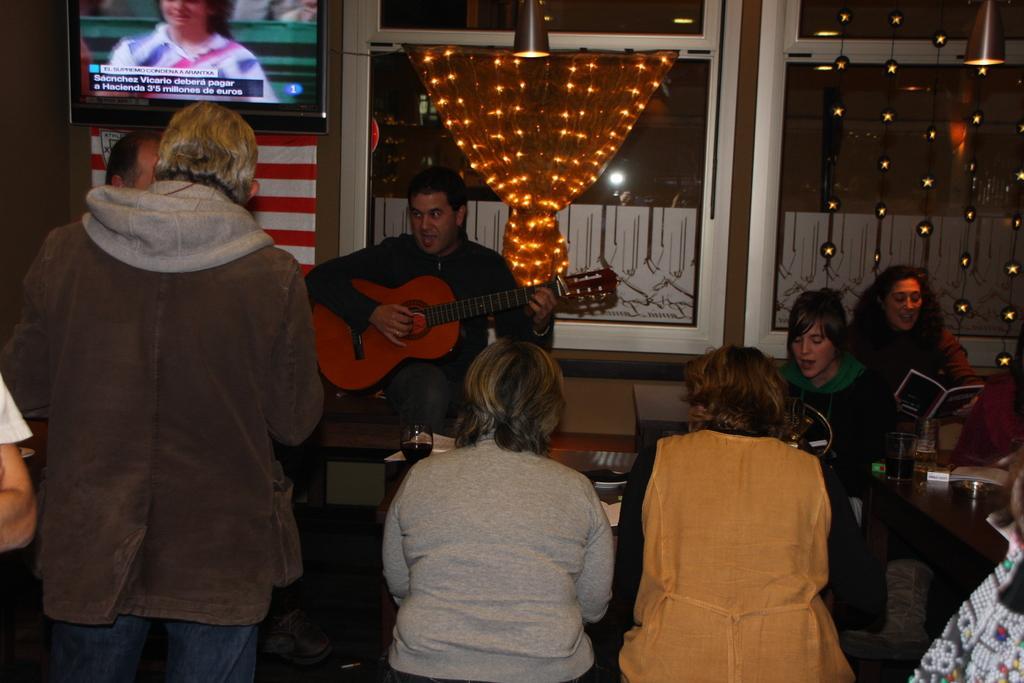Can you describe this image briefly? In this image I see few people who are sitting and this woman is holding a book and this man holding a guitar in his hands, I can also there is a television over here. In the background I see the lights. 